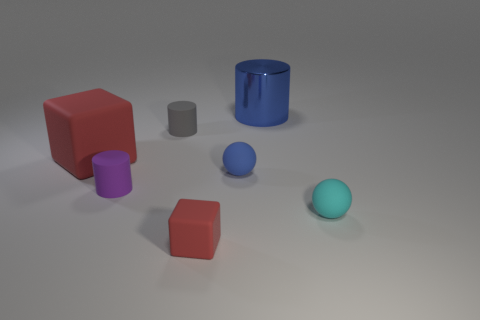Subtract all gray cylinders. Subtract all purple blocks. How many cylinders are left? 2 Add 2 cylinders. How many objects exist? 9 Subtract all balls. How many objects are left? 5 Subtract 0 purple cubes. How many objects are left? 7 Subtract all small brown objects. Subtract all small matte spheres. How many objects are left? 5 Add 3 cubes. How many cubes are left? 5 Add 1 tiny blue rubber balls. How many tiny blue rubber balls exist? 2 